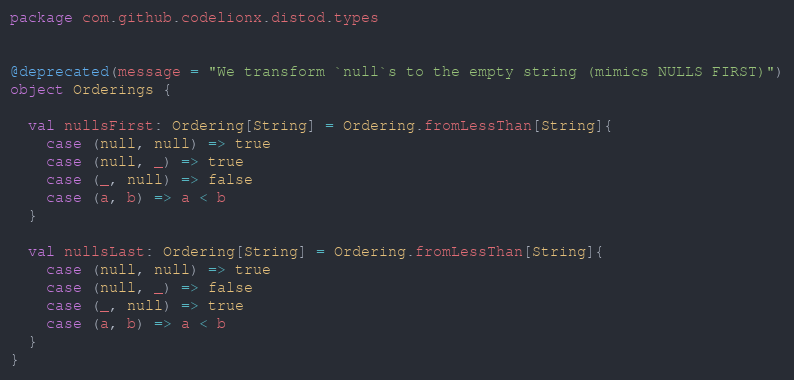<code> <loc_0><loc_0><loc_500><loc_500><_Scala_>package com.github.codelionx.distod.types


@deprecated(message = "We transform `null`s to the empty string (mimics NULLS FIRST)")
object Orderings {

  val nullsFirst: Ordering[String] = Ordering.fromLessThan[String]{
    case (null, null) => true
    case (null, _) => true
    case (_, null) => false
    case (a, b) => a < b
  }

  val nullsLast: Ordering[String] = Ordering.fromLessThan[String]{
    case (null, null) => true
    case (null, _) => false
    case (_, null) => true
    case (a, b) => a < b
  }
}
</code> 